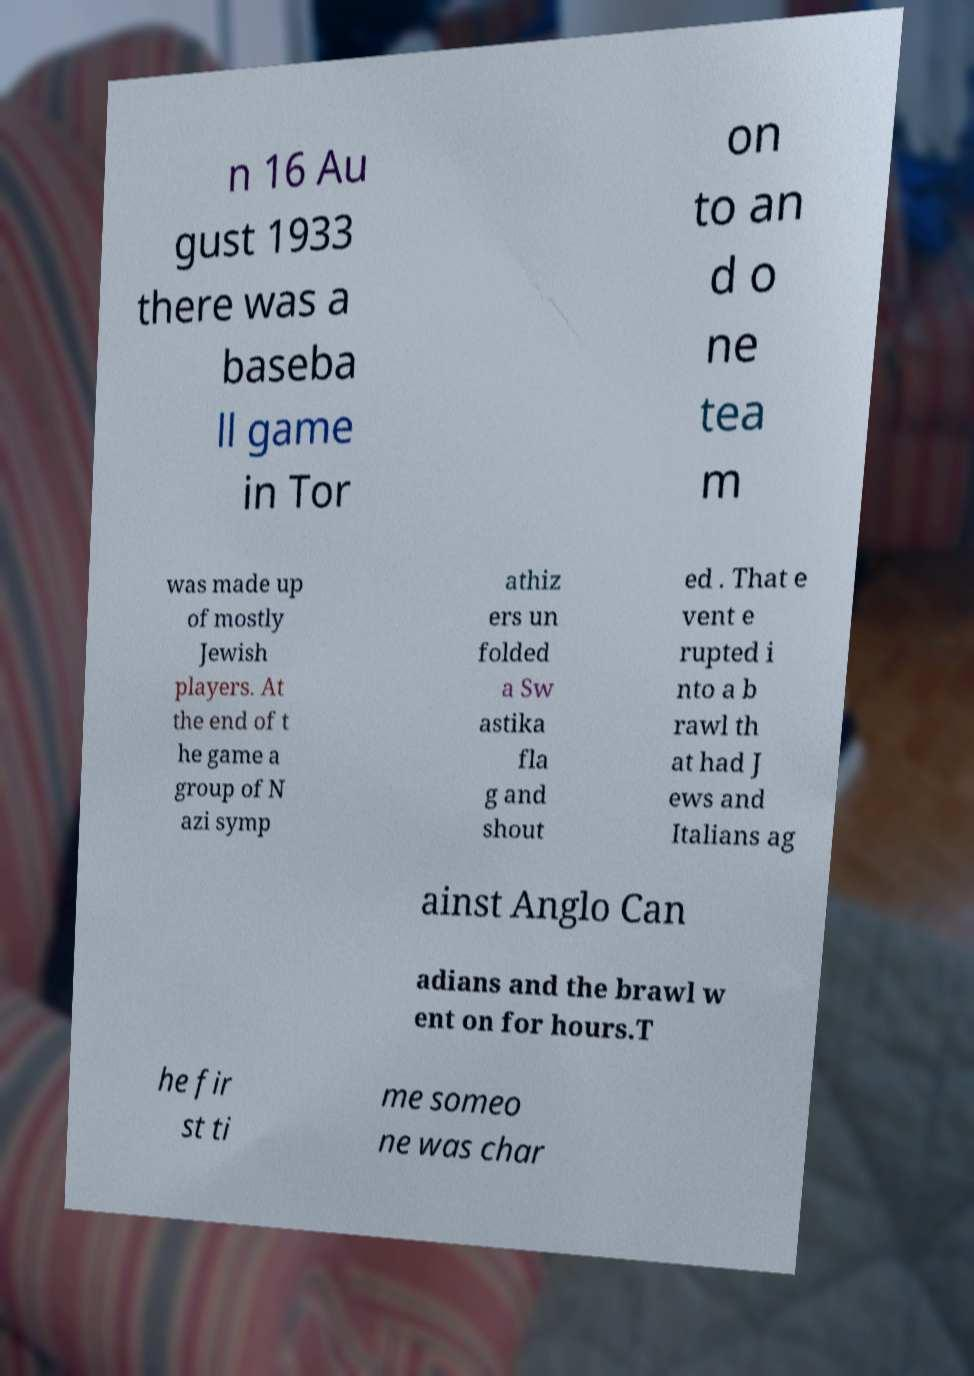Could you extract and type out the text from this image? n 16 Au gust 1933 there was a baseba ll game in Tor on to an d o ne tea m was made up of mostly Jewish players. At the end of t he game a group of N azi symp athiz ers un folded a Sw astika fla g and shout ed . That e vent e rupted i nto a b rawl th at had J ews and Italians ag ainst Anglo Can adians and the brawl w ent on for hours.T he fir st ti me someo ne was char 